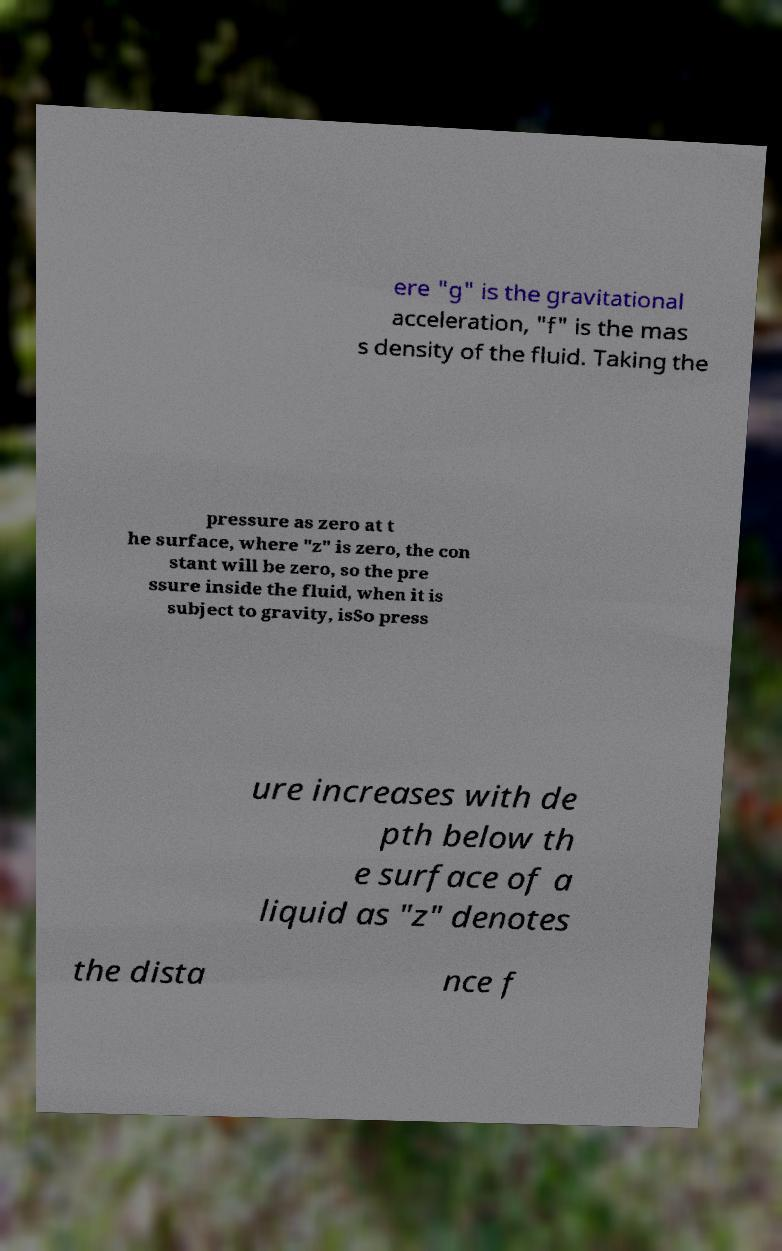Please identify and transcribe the text found in this image. ere "g" is the gravitational acceleration, "f" is the mas s density of the fluid. Taking the pressure as zero at t he surface, where "z" is zero, the con stant will be zero, so the pre ssure inside the fluid, when it is subject to gravity, isSo press ure increases with de pth below th e surface of a liquid as "z" denotes the dista nce f 